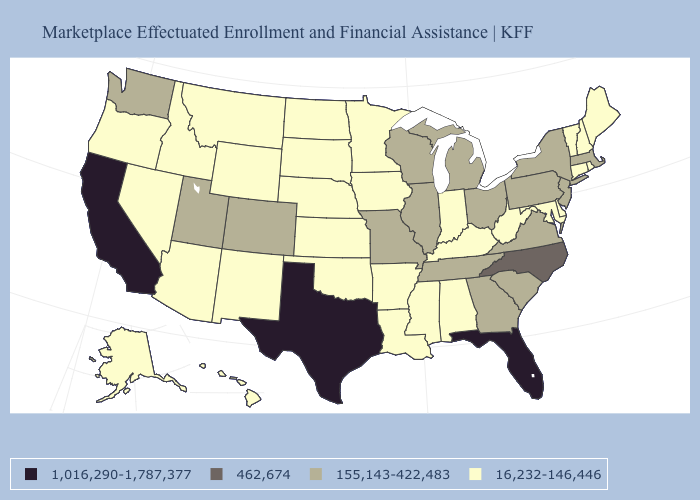Which states have the lowest value in the West?
Write a very short answer. Alaska, Arizona, Hawaii, Idaho, Montana, Nevada, New Mexico, Oregon, Wyoming. What is the lowest value in the USA?
Be succinct. 16,232-146,446. Name the states that have a value in the range 1,016,290-1,787,377?
Concise answer only. California, Florida, Texas. What is the value of Delaware?
Give a very brief answer. 16,232-146,446. Does Minnesota have a higher value than South Carolina?
Be succinct. No. Which states have the lowest value in the USA?
Short answer required. Alabama, Alaska, Arizona, Arkansas, Connecticut, Delaware, Hawaii, Idaho, Indiana, Iowa, Kansas, Kentucky, Louisiana, Maine, Maryland, Minnesota, Mississippi, Montana, Nebraska, Nevada, New Hampshire, New Mexico, North Dakota, Oklahoma, Oregon, Rhode Island, South Dakota, Vermont, West Virginia, Wyoming. What is the lowest value in the South?
Short answer required. 16,232-146,446. What is the value of Montana?
Keep it brief. 16,232-146,446. Does the first symbol in the legend represent the smallest category?
Answer briefly. No. What is the lowest value in the USA?
Concise answer only. 16,232-146,446. How many symbols are there in the legend?
Short answer required. 4. Name the states that have a value in the range 155,143-422,483?
Concise answer only. Colorado, Georgia, Illinois, Massachusetts, Michigan, Missouri, New Jersey, New York, Ohio, Pennsylvania, South Carolina, Tennessee, Utah, Virginia, Washington, Wisconsin. Which states have the lowest value in the South?
Short answer required. Alabama, Arkansas, Delaware, Kentucky, Louisiana, Maryland, Mississippi, Oklahoma, West Virginia. Which states have the highest value in the USA?
Short answer required. California, Florida, Texas. Does Wisconsin have the highest value in the USA?
Keep it brief. No. 